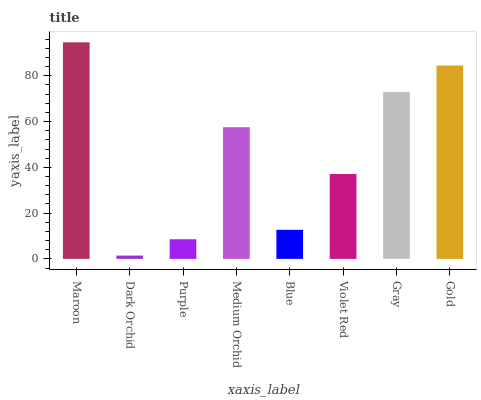Is Dark Orchid the minimum?
Answer yes or no. Yes. Is Maroon the maximum?
Answer yes or no. Yes. Is Purple the minimum?
Answer yes or no. No. Is Purple the maximum?
Answer yes or no. No. Is Purple greater than Dark Orchid?
Answer yes or no. Yes. Is Dark Orchid less than Purple?
Answer yes or no. Yes. Is Dark Orchid greater than Purple?
Answer yes or no. No. Is Purple less than Dark Orchid?
Answer yes or no. No. Is Medium Orchid the high median?
Answer yes or no. Yes. Is Violet Red the low median?
Answer yes or no. Yes. Is Maroon the high median?
Answer yes or no. No. Is Purple the low median?
Answer yes or no. No. 